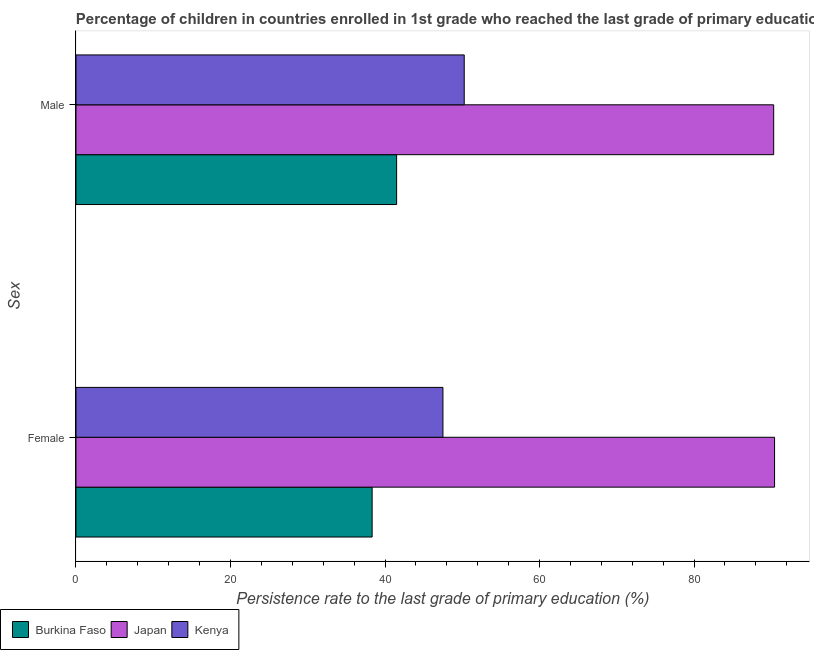How many groups of bars are there?
Provide a succinct answer. 2. Are the number of bars per tick equal to the number of legend labels?
Make the answer very short. Yes. How many bars are there on the 1st tick from the bottom?
Ensure brevity in your answer.  3. What is the persistence rate of female students in Kenya?
Provide a succinct answer. 47.49. Across all countries, what is the maximum persistence rate of male students?
Make the answer very short. 90.31. Across all countries, what is the minimum persistence rate of female students?
Offer a terse response. 38.33. In which country was the persistence rate of female students minimum?
Offer a terse response. Burkina Faso. What is the total persistence rate of female students in the graph?
Offer a very short reply. 176.25. What is the difference between the persistence rate of female students in Burkina Faso and that in Kenya?
Ensure brevity in your answer.  -9.16. What is the difference between the persistence rate of female students in Kenya and the persistence rate of male students in Burkina Faso?
Offer a terse response. 5.99. What is the average persistence rate of female students per country?
Your answer should be very brief. 58.75. What is the difference between the persistence rate of male students and persistence rate of female students in Kenya?
Make the answer very short. 2.76. What is the ratio of the persistence rate of female students in Japan to that in Kenya?
Your answer should be compact. 1.9. Is the persistence rate of male students in Burkina Faso less than that in Kenya?
Offer a very short reply. Yes. What does the 1st bar from the top in Male represents?
Give a very brief answer. Kenya. What does the 3rd bar from the bottom in Male represents?
Offer a very short reply. Kenya. How many bars are there?
Your answer should be compact. 6. Are all the bars in the graph horizontal?
Your answer should be compact. Yes. What is the difference between two consecutive major ticks on the X-axis?
Your answer should be compact. 20. Does the graph contain any zero values?
Give a very brief answer. No. Does the graph contain grids?
Keep it short and to the point. No. Where does the legend appear in the graph?
Give a very brief answer. Bottom left. How many legend labels are there?
Your answer should be very brief. 3. How are the legend labels stacked?
Give a very brief answer. Horizontal. What is the title of the graph?
Your response must be concise. Percentage of children in countries enrolled in 1st grade who reached the last grade of primary education. Does "Kuwait" appear as one of the legend labels in the graph?
Your answer should be very brief. No. What is the label or title of the X-axis?
Keep it short and to the point. Persistence rate to the last grade of primary education (%). What is the label or title of the Y-axis?
Keep it short and to the point. Sex. What is the Persistence rate to the last grade of primary education (%) in Burkina Faso in Female?
Offer a very short reply. 38.33. What is the Persistence rate to the last grade of primary education (%) in Japan in Female?
Offer a very short reply. 90.42. What is the Persistence rate to the last grade of primary education (%) in Kenya in Female?
Your answer should be very brief. 47.49. What is the Persistence rate to the last grade of primary education (%) in Burkina Faso in Male?
Your answer should be compact. 41.5. What is the Persistence rate to the last grade of primary education (%) of Japan in Male?
Make the answer very short. 90.31. What is the Persistence rate to the last grade of primary education (%) in Kenya in Male?
Offer a very short reply. 50.25. Across all Sex, what is the maximum Persistence rate to the last grade of primary education (%) of Burkina Faso?
Your answer should be compact. 41.5. Across all Sex, what is the maximum Persistence rate to the last grade of primary education (%) in Japan?
Offer a terse response. 90.42. Across all Sex, what is the maximum Persistence rate to the last grade of primary education (%) in Kenya?
Your answer should be compact. 50.25. Across all Sex, what is the minimum Persistence rate to the last grade of primary education (%) in Burkina Faso?
Offer a terse response. 38.33. Across all Sex, what is the minimum Persistence rate to the last grade of primary education (%) in Japan?
Keep it short and to the point. 90.31. Across all Sex, what is the minimum Persistence rate to the last grade of primary education (%) in Kenya?
Keep it short and to the point. 47.49. What is the total Persistence rate to the last grade of primary education (%) of Burkina Faso in the graph?
Keep it short and to the point. 79.83. What is the total Persistence rate to the last grade of primary education (%) in Japan in the graph?
Keep it short and to the point. 180.72. What is the total Persistence rate to the last grade of primary education (%) of Kenya in the graph?
Your answer should be very brief. 97.75. What is the difference between the Persistence rate to the last grade of primary education (%) in Burkina Faso in Female and that in Male?
Keep it short and to the point. -3.17. What is the difference between the Persistence rate to the last grade of primary education (%) in Japan in Female and that in Male?
Provide a short and direct response. 0.11. What is the difference between the Persistence rate to the last grade of primary education (%) of Kenya in Female and that in Male?
Your answer should be very brief. -2.76. What is the difference between the Persistence rate to the last grade of primary education (%) in Burkina Faso in Female and the Persistence rate to the last grade of primary education (%) in Japan in Male?
Make the answer very short. -51.97. What is the difference between the Persistence rate to the last grade of primary education (%) of Burkina Faso in Female and the Persistence rate to the last grade of primary education (%) of Kenya in Male?
Your answer should be compact. -11.92. What is the difference between the Persistence rate to the last grade of primary education (%) of Japan in Female and the Persistence rate to the last grade of primary education (%) of Kenya in Male?
Make the answer very short. 40.17. What is the average Persistence rate to the last grade of primary education (%) of Burkina Faso per Sex?
Give a very brief answer. 39.92. What is the average Persistence rate to the last grade of primary education (%) in Japan per Sex?
Make the answer very short. 90.36. What is the average Persistence rate to the last grade of primary education (%) in Kenya per Sex?
Offer a terse response. 48.87. What is the difference between the Persistence rate to the last grade of primary education (%) in Burkina Faso and Persistence rate to the last grade of primary education (%) in Japan in Female?
Make the answer very short. -52.09. What is the difference between the Persistence rate to the last grade of primary education (%) of Burkina Faso and Persistence rate to the last grade of primary education (%) of Kenya in Female?
Your answer should be compact. -9.16. What is the difference between the Persistence rate to the last grade of primary education (%) in Japan and Persistence rate to the last grade of primary education (%) in Kenya in Female?
Your answer should be compact. 42.92. What is the difference between the Persistence rate to the last grade of primary education (%) of Burkina Faso and Persistence rate to the last grade of primary education (%) of Japan in Male?
Your response must be concise. -48.81. What is the difference between the Persistence rate to the last grade of primary education (%) in Burkina Faso and Persistence rate to the last grade of primary education (%) in Kenya in Male?
Your answer should be very brief. -8.75. What is the difference between the Persistence rate to the last grade of primary education (%) in Japan and Persistence rate to the last grade of primary education (%) in Kenya in Male?
Make the answer very short. 40.05. What is the ratio of the Persistence rate to the last grade of primary education (%) of Burkina Faso in Female to that in Male?
Your response must be concise. 0.92. What is the ratio of the Persistence rate to the last grade of primary education (%) in Kenya in Female to that in Male?
Offer a very short reply. 0.95. What is the difference between the highest and the second highest Persistence rate to the last grade of primary education (%) of Burkina Faso?
Ensure brevity in your answer.  3.17. What is the difference between the highest and the second highest Persistence rate to the last grade of primary education (%) of Japan?
Keep it short and to the point. 0.11. What is the difference between the highest and the second highest Persistence rate to the last grade of primary education (%) of Kenya?
Give a very brief answer. 2.76. What is the difference between the highest and the lowest Persistence rate to the last grade of primary education (%) in Burkina Faso?
Keep it short and to the point. 3.17. What is the difference between the highest and the lowest Persistence rate to the last grade of primary education (%) of Japan?
Your answer should be compact. 0.11. What is the difference between the highest and the lowest Persistence rate to the last grade of primary education (%) in Kenya?
Your response must be concise. 2.76. 